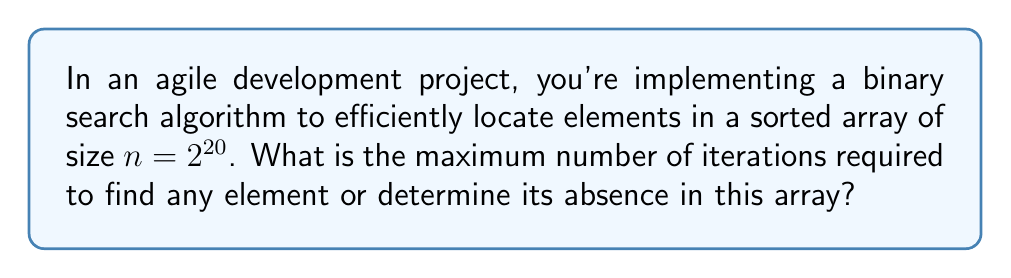Teach me how to tackle this problem. Let's approach this step-by-step:

1) In a binary search algorithm, the search space is halved in each iteration.

2) The initial size of the array is $n = 2^{20}$.

3) After each iteration, the size of the search space becomes:
   - 1st iteration: $2^{19}$
   - 2nd iteration: $2^{18}$
   - 3rd iteration: $2^{17}$
   ...and so on.

4) The search terminates when the search space is reduced to 1 (either the element is found or it's determined to be absent).

5) We need to find how many times we need to divide $2^{20}$ by 2 to get 1.

6) Mathematically, we're solving for $k$ in the equation:

   $$2^{20} \div 2^k = 1$$

7) This can be rewritten as:

   $$2^{20-k} = 1$$

8) Taking the logarithm of both sides:

   $$20 - k = 0$$

9) Solving for $k$:

   $$k = 20$$

Thus, in the worst-case scenario, it will take 20 iterations to find an element or determine its absence in the array.
Answer: 20 iterations 